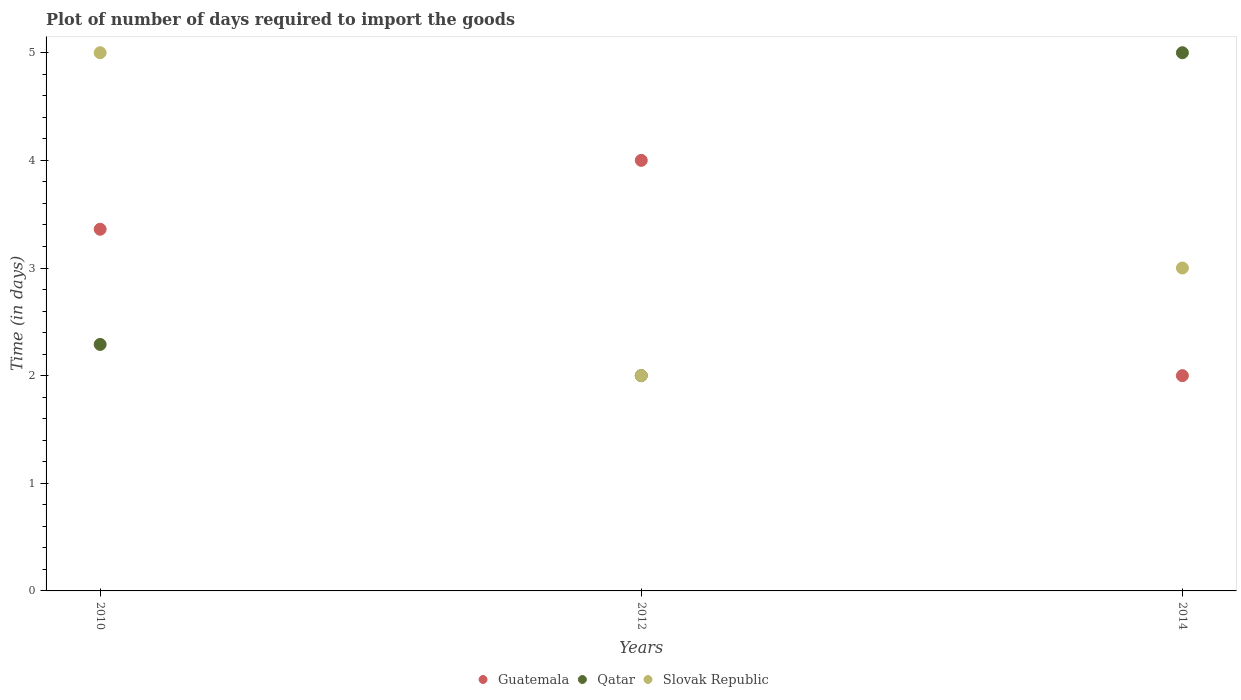How many different coloured dotlines are there?
Offer a terse response. 3. Is the number of dotlines equal to the number of legend labels?
Provide a short and direct response. Yes. What is the time required to import goods in Guatemala in 2014?
Your answer should be very brief. 2. Across all years, what is the maximum time required to import goods in Qatar?
Your answer should be very brief. 5. Across all years, what is the minimum time required to import goods in Slovak Republic?
Your answer should be very brief. 2. In which year was the time required to import goods in Qatar minimum?
Provide a short and direct response. 2012. What is the total time required to import goods in Slovak Republic in the graph?
Keep it short and to the point. 10. What is the difference between the time required to import goods in Slovak Republic in 2010 and that in 2012?
Offer a very short reply. 3. What is the difference between the time required to import goods in Qatar in 2014 and the time required to import goods in Slovak Republic in 2012?
Offer a very short reply. 3. What is the average time required to import goods in Guatemala per year?
Provide a succinct answer. 3.12. In the year 2010, what is the difference between the time required to import goods in Slovak Republic and time required to import goods in Qatar?
Keep it short and to the point. 2.71. In how many years, is the time required to import goods in Guatemala greater than 3.8 days?
Provide a short and direct response. 1. What is the ratio of the time required to import goods in Slovak Republic in 2010 to that in 2012?
Make the answer very short. 2.5. Is the time required to import goods in Guatemala in 2012 less than that in 2014?
Offer a very short reply. No. What is the difference between the highest and the second highest time required to import goods in Qatar?
Offer a very short reply. 2.71. What is the difference between the highest and the lowest time required to import goods in Guatemala?
Ensure brevity in your answer.  2. Is the sum of the time required to import goods in Guatemala in 2012 and 2014 greater than the maximum time required to import goods in Qatar across all years?
Provide a short and direct response. Yes. Is it the case that in every year, the sum of the time required to import goods in Guatemala and time required to import goods in Slovak Republic  is greater than the time required to import goods in Qatar?
Offer a very short reply. No. Does the time required to import goods in Qatar monotonically increase over the years?
Your answer should be very brief. No. Is the time required to import goods in Guatemala strictly less than the time required to import goods in Slovak Republic over the years?
Your answer should be compact. No. Does the graph contain any zero values?
Ensure brevity in your answer.  No. Where does the legend appear in the graph?
Offer a very short reply. Bottom center. How many legend labels are there?
Offer a terse response. 3. How are the legend labels stacked?
Make the answer very short. Horizontal. What is the title of the graph?
Provide a succinct answer. Plot of number of days required to import the goods. What is the label or title of the Y-axis?
Offer a very short reply. Time (in days). What is the Time (in days) in Guatemala in 2010?
Ensure brevity in your answer.  3.36. What is the Time (in days) in Qatar in 2010?
Ensure brevity in your answer.  2.29. What is the Time (in days) of Slovak Republic in 2010?
Give a very brief answer. 5. What is the Time (in days) in Guatemala in 2012?
Your response must be concise. 4. What is the Time (in days) of Qatar in 2014?
Keep it short and to the point. 5. What is the Time (in days) of Slovak Republic in 2014?
Ensure brevity in your answer.  3. Across all years, what is the maximum Time (in days) in Guatemala?
Provide a succinct answer. 4. Across all years, what is the maximum Time (in days) of Slovak Republic?
Your answer should be compact. 5. Across all years, what is the minimum Time (in days) of Guatemala?
Give a very brief answer. 2. What is the total Time (in days) in Guatemala in the graph?
Ensure brevity in your answer.  9.36. What is the total Time (in days) of Qatar in the graph?
Your answer should be compact. 9.29. What is the difference between the Time (in days) of Guatemala in 2010 and that in 2012?
Keep it short and to the point. -0.64. What is the difference between the Time (in days) of Qatar in 2010 and that in 2012?
Give a very brief answer. 0.29. What is the difference between the Time (in days) in Slovak Republic in 2010 and that in 2012?
Give a very brief answer. 3. What is the difference between the Time (in days) in Guatemala in 2010 and that in 2014?
Offer a terse response. 1.36. What is the difference between the Time (in days) in Qatar in 2010 and that in 2014?
Ensure brevity in your answer.  -2.71. What is the difference between the Time (in days) in Guatemala in 2012 and that in 2014?
Make the answer very short. 2. What is the difference between the Time (in days) of Guatemala in 2010 and the Time (in days) of Qatar in 2012?
Offer a very short reply. 1.36. What is the difference between the Time (in days) of Guatemala in 2010 and the Time (in days) of Slovak Republic in 2012?
Offer a terse response. 1.36. What is the difference between the Time (in days) in Qatar in 2010 and the Time (in days) in Slovak Republic in 2012?
Provide a succinct answer. 0.29. What is the difference between the Time (in days) of Guatemala in 2010 and the Time (in days) of Qatar in 2014?
Keep it short and to the point. -1.64. What is the difference between the Time (in days) in Guatemala in 2010 and the Time (in days) in Slovak Republic in 2014?
Ensure brevity in your answer.  0.36. What is the difference between the Time (in days) of Qatar in 2010 and the Time (in days) of Slovak Republic in 2014?
Give a very brief answer. -0.71. What is the difference between the Time (in days) in Guatemala in 2012 and the Time (in days) in Slovak Republic in 2014?
Offer a very short reply. 1. What is the average Time (in days) in Guatemala per year?
Provide a succinct answer. 3.12. What is the average Time (in days) in Qatar per year?
Ensure brevity in your answer.  3.1. What is the average Time (in days) in Slovak Republic per year?
Your response must be concise. 3.33. In the year 2010, what is the difference between the Time (in days) of Guatemala and Time (in days) of Qatar?
Your answer should be compact. 1.07. In the year 2010, what is the difference between the Time (in days) of Guatemala and Time (in days) of Slovak Republic?
Provide a short and direct response. -1.64. In the year 2010, what is the difference between the Time (in days) in Qatar and Time (in days) in Slovak Republic?
Your answer should be compact. -2.71. In the year 2012, what is the difference between the Time (in days) in Guatemala and Time (in days) in Slovak Republic?
Your response must be concise. 2. In the year 2012, what is the difference between the Time (in days) in Qatar and Time (in days) in Slovak Republic?
Your answer should be very brief. 0. In the year 2014, what is the difference between the Time (in days) of Guatemala and Time (in days) of Slovak Republic?
Offer a terse response. -1. In the year 2014, what is the difference between the Time (in days) of Qatar and Time (in days) of Slovak Republic?
Keep it short and to the point. 2. What is the ratio of the Time (in days) of Guatemala in 2010 to that in 2012?
Your response must be concise. 0.84. What is the ratio of the Time (in days) of Qatar in 2010 to that in 2012?
Make the answer very short. 1.15. What is the ratio of the Time (in days) of Slovak Republic in 2010 to that in 2012?
Your answer should be very brief. 2.5. What is the ratio of the Time (in days) of Guatemala in 2010 to that in 2014?
Offer a very short reply. 1.68. What is the ratio of the Time (in days) in Qatar in 2010 to that in 2014?
Keep it short and to the point. 0.46. What is the ratio of the Time (in days) of Guatemala in 2012 to that in 2014?
Give a very brief answer. 2. What is the ratio of the Time (in days) in Slovak Republic in 2012 to that in 2014?
Provide a succinct answer. 0.67. What is the difference between the highest and the second highest Time (in days) of Guatemala?
Provide a short and direct response. 0.64. What is the difference between the highest and the second highest Time (in days) in Qatar?
Ensure brevity in your answer.  2.71. What is the difference between the highest and the lowest Time (in days) of Slovak Republic?
Make the answer very short. 3. 